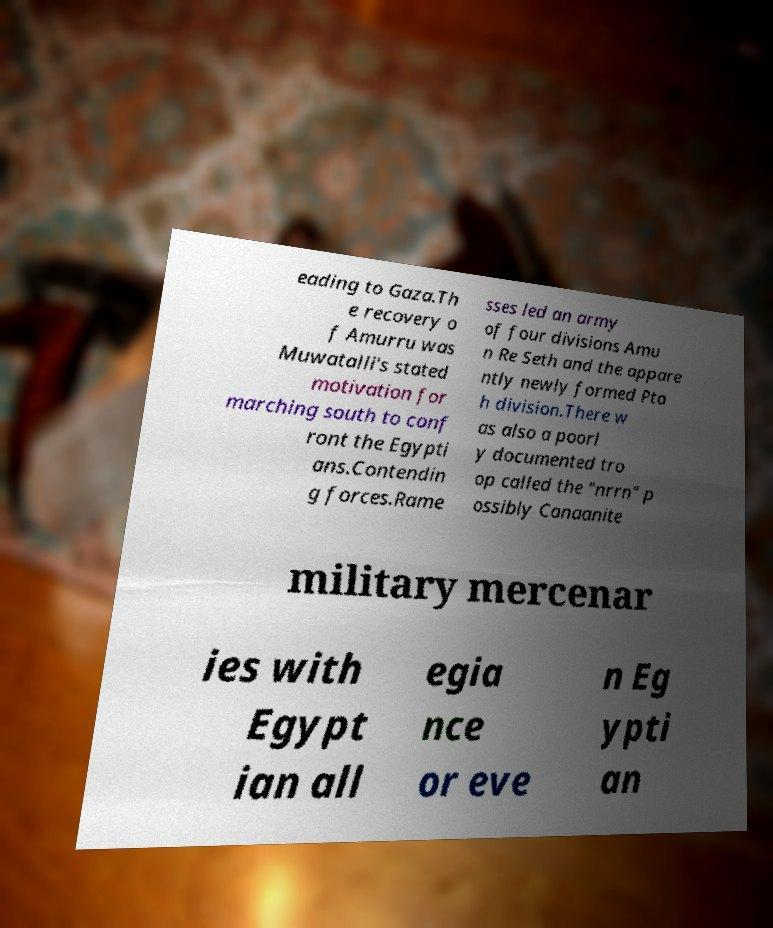Could you extract and type out the text from this image? eading to Gaza.Th e recovery o f Amurru was Muwatalli's stated motivation for marching south to conf ront the Egypti ans.Contendin g forces.Rame sses led an army of four divisions Amu n Re Seth and the appare ntly newly formed Pta h division.There w as also a poorl y documented tro op called the "nrrn" p ossibly Canaanite military mercenar ies with Egypt ian all egia nce or eve n Eg ypti an 